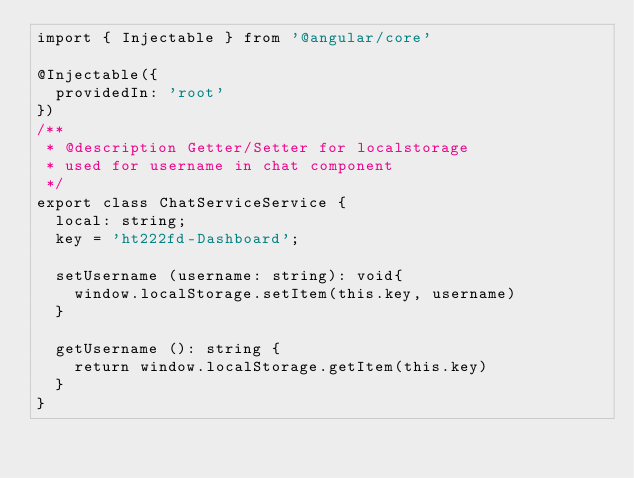Convert code to text. <code><loc_0><loc_0><loc_500><loc_500><_TypeScript_>import { Injectable } from '@angular/core'

@Injectable({
  providedIn: 'root'
})
/**
 * @description Getter/Setter for localstorage
 * used for username in chat component
 */
export class ChatServiceService {
  local: string;
  key = 'ht222fd-Dashboard';

  setUsername (username: string): void{
    window.localStorage.setItem(this.key, username)
  }

  getUsername (): string {
    return window.localStorage.getItem(this.key)
  }
}
</code> 